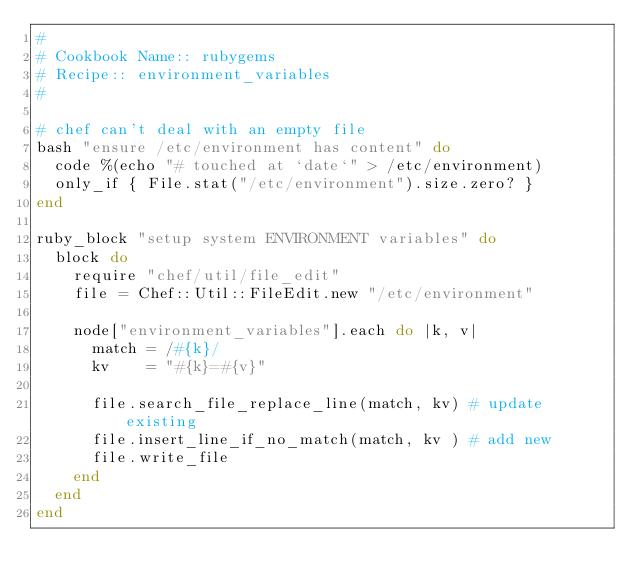<code> <loc_0><loc_0><loc_500><loc_500><_Ruby_>#
# Cookbook Name:: rubygems
# Recipe:: environment_variables
#

# chef can't deal with an empty file
bash "ensure /etc/environment has content" do
  code %(echo "# touched at `date`" > /etc/environment)
  only_if { File.stat("/etc/environment").size.zero? }
end

ruby_block "setup system ENVIRONMENT variables" do
  block do
    require "chef/util/file_edit"
    file = Chef::Util::FileEdit.new "/etc/environment"

    node["environment_variables"].each do |k, v|
      match = /#{k}/
      kv    = "#{k}=#{v}"

      file.search_file_replace_line(match, kv) # update existing
      file.insert_line_if_no_match(match, kv ) # add new
      file.write_file
    end
  end
end
</code> 